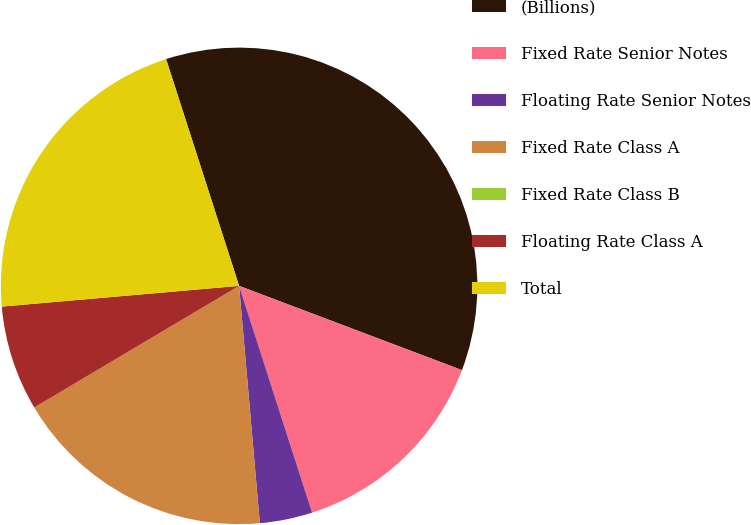Convert chart to OTSL. <chart><loc_0><loc_0><loc_500><loc_500><pie_chart><fcel>(Billions)<fcel>Fixed Rate Senior Notes<fcel>Floating Rate Senior Notes<fcel>Fixed Rate Class A<fcel>Fixed Rate Class B<fcel>Floating Rate Class A<fcel>Total<nl><fcel>35.71%<fcel>14.29%<fcel>3.57%<fcel>17.86%<fcel>0.0%<fcel>7.14%<fcel>21.43%<nl></chart> 